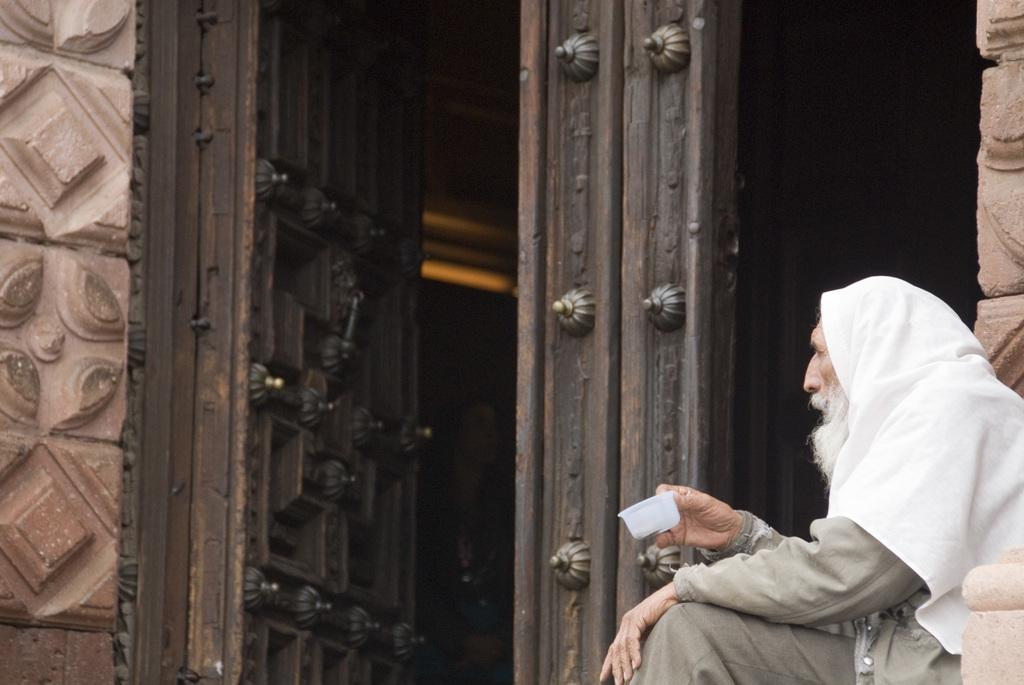What is located in the foreground of the image? There is a wall and doors in the foreground of the image. What is the person in the foreground of the image doing? The person is sitting in the foreground of the image and holding a box in their hand. Can you describe the time of day when the image was taken? The image was taken during the day. What type of collar is the person wearing in the image? There is no collar visible in the image, as the person is not wearing any clothing or accessories that would include a collar. What kind of stocking is hanging on the wall in the image? There is no stocking present in the image; only a wall, doors, and a person sitting with a box are visible. 